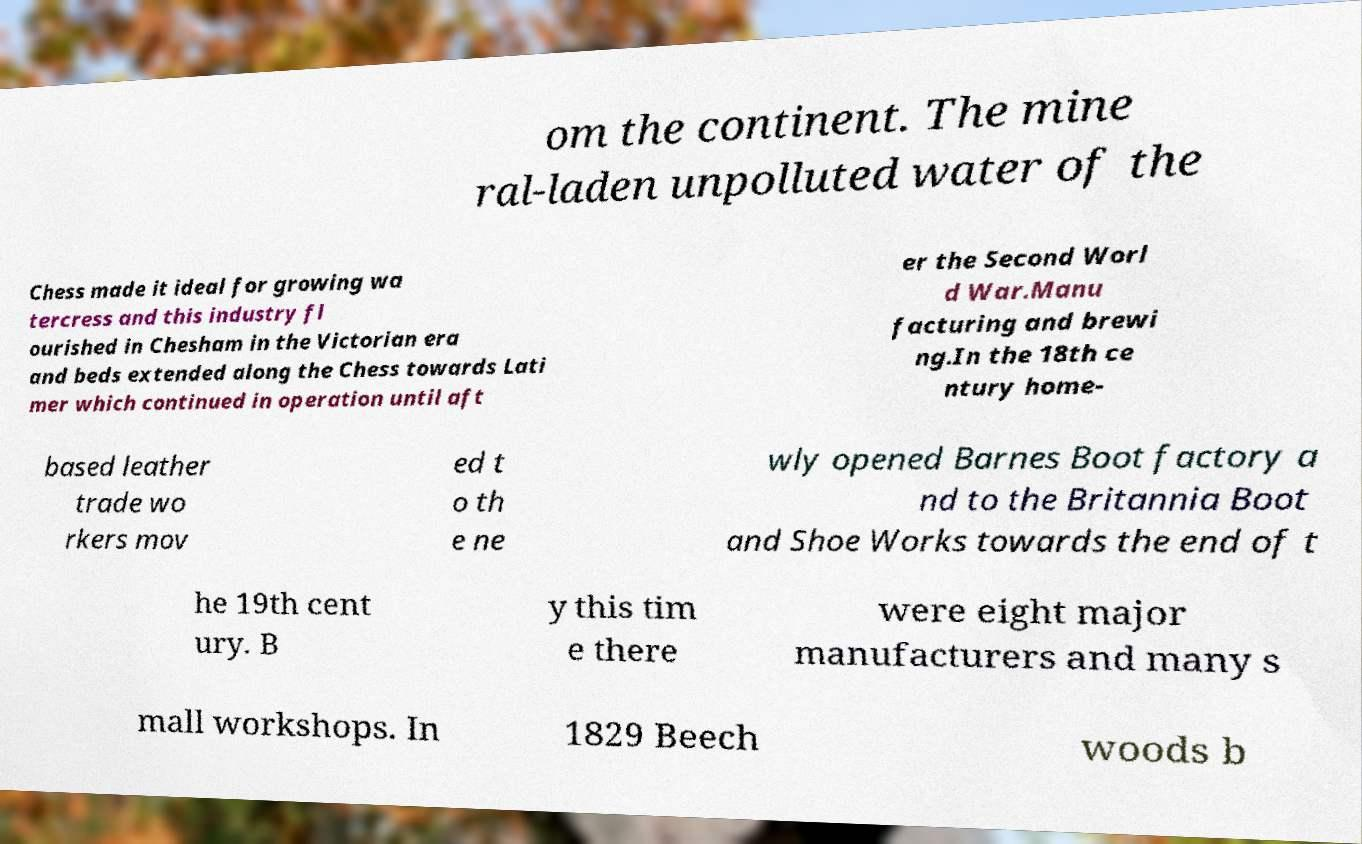Please identify and transcribe the text found in this image. om the continent. The mine ral-laden unpolluted water of the Chess made it ideal for growing wa tercress and this industry fl ourished in Chesham in the Victorian era and beds extended along the Chess towards Lati mer which continued in operation until aft er the Second Worl d War.Manu facturing and brewi ng.In the 18th ce ntury home- based leather trade wo rkers mov ed t o th e ne wly opened Barnes Boot factory a nd to the Britannia Boot and Shoe Works towards the end of t he 19th cent ury. B y this tim e there were eight major manufacturers and many s mall workshops. In 1829 Beech woods b 